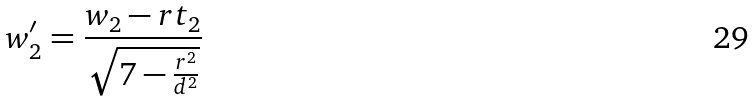Convert formula to latex. <formula><loc_0><loc_0><loc_500><loc_500>w _ { 2 } ^ { \prime } = \frac { w _ { 2 } - r t _ { 2 } } { \sqrt { 7 - \frac { r ^ { 2 } } { d ^ { 2 } } } }</formula> 